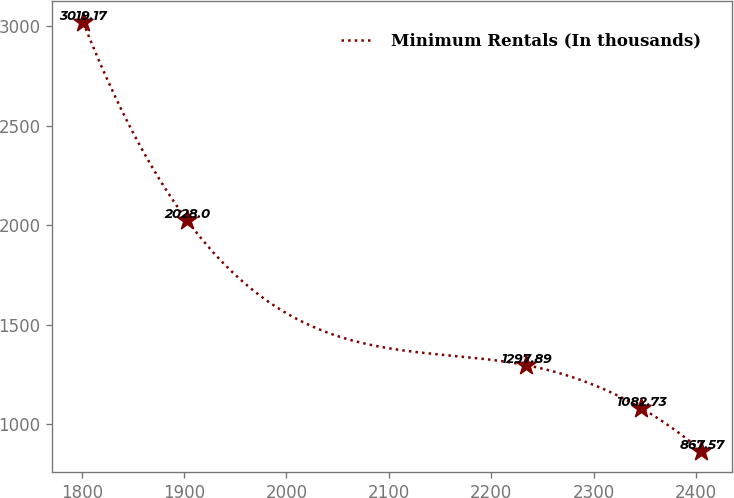Convert chart. <chart><loc_0><loc_0><loc_500><loc_500><line_chart><ecel><fcel>Minimum Rentals (In thousands)<nl><fcel>1801.42<fcel>3019.17<nl><fcel>1902.52<fcel>2028<nl><fcel>2233.63<fcel>1297.89<nl><fcel>2346.2<fcel>1082.73<nl><fcel>2405.36<fcel>867.57<nl></chart> 